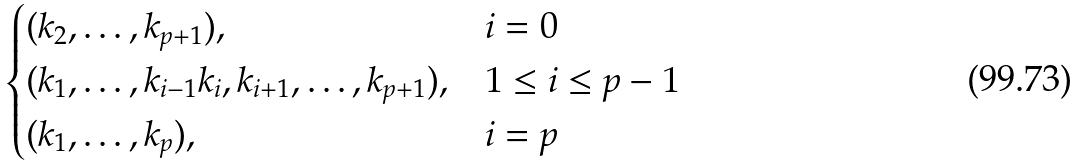<formula> <loc_0><loc_0><loc_500><loc_500>\begin{cases} ( k _ { 2 } , \dots , k _ { p + 1 } ) , & i = 0 \\ ( k _ { 1 } , \dots , k _ { i - 1 } k _ { i } , k _ { i + 1 } , \dots , k _ { p + 1 } ) , & 1 \leq i \leq p - 1 \\ ( k _ { 1 } , \dots , k _ { p } ) , & i = p \end{cases}</formula> 